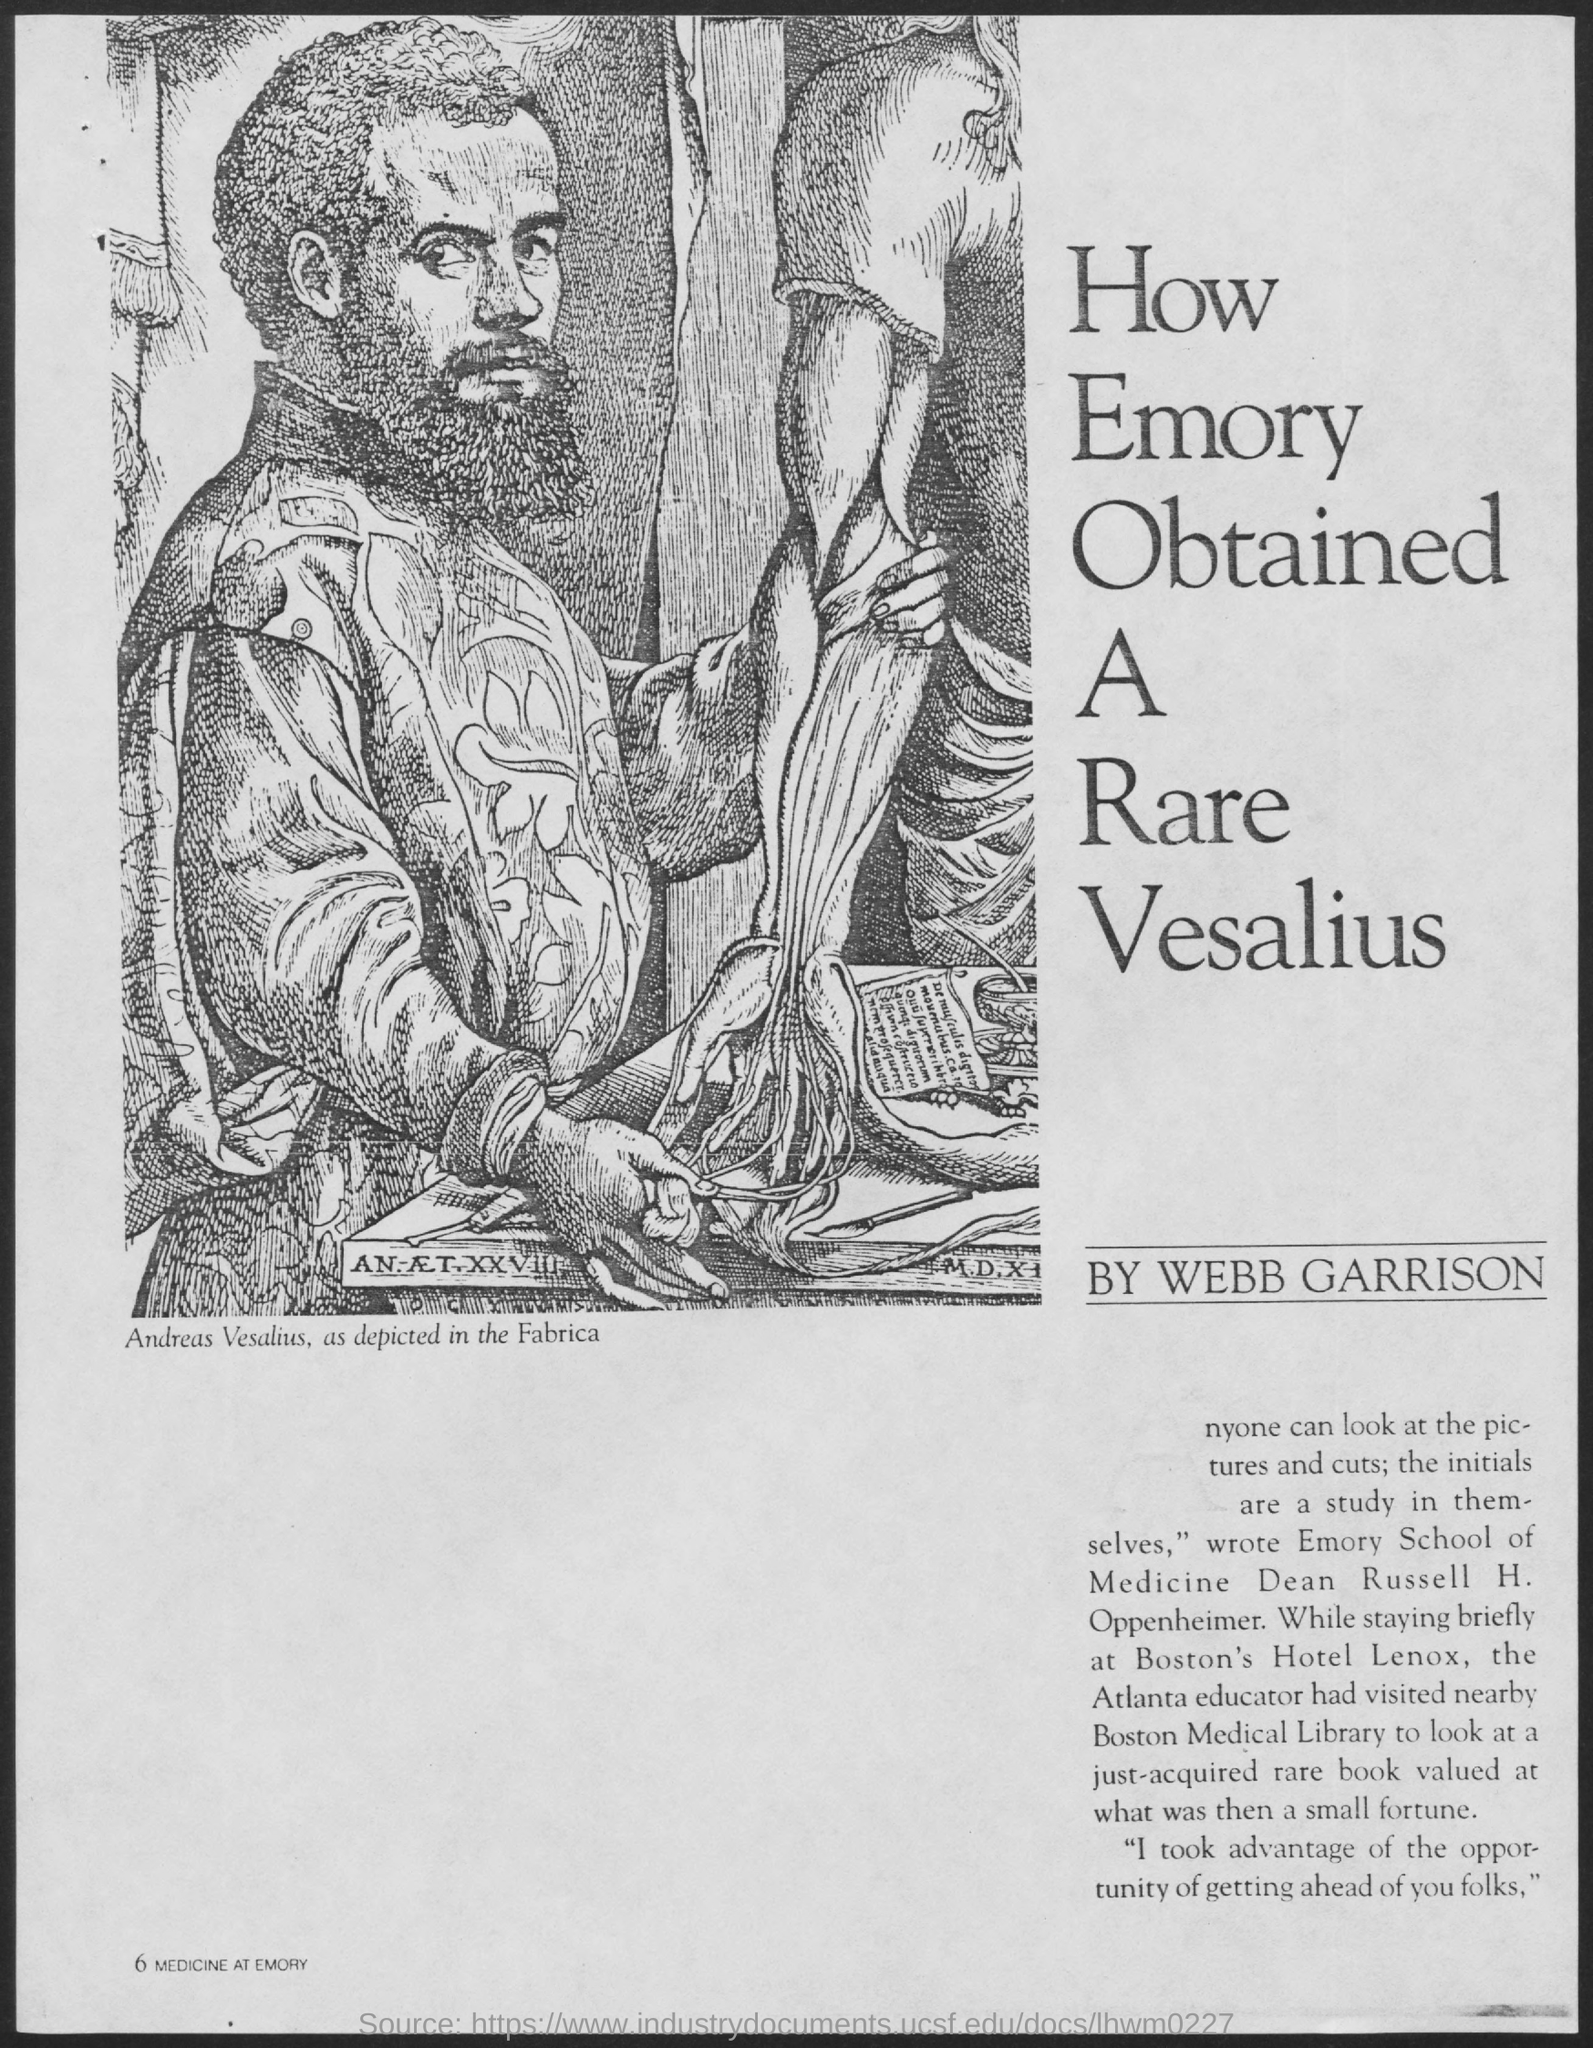Can you describe the context of this engraving from the image? This engraving shows Andreas Vesalius standing beside a dissection table, a depiction from his famous work 'De Humani Corporis Fabrica'. The scene underscores the hands-on approach and the direct observation methods that Vesalius promoted, which were instrumental in advancing medical science during the Renaissance. 